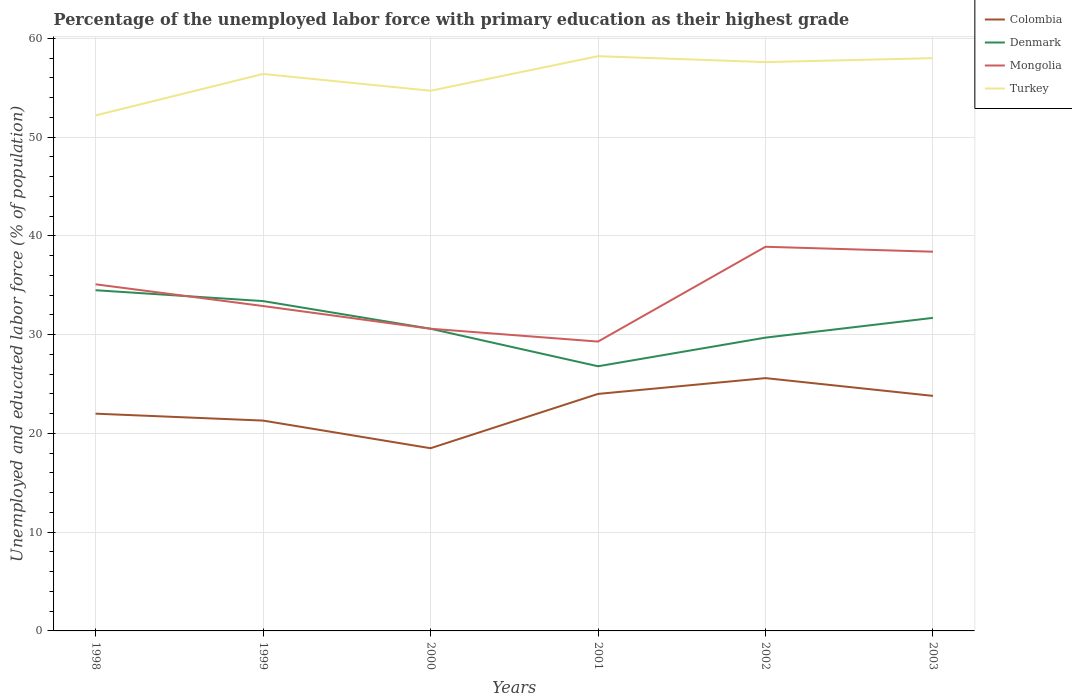Across all years, what is the maximum percentage of the unemployed labor force with primary education in Denmark?
Give a very brief answer. 26.8. What is the total percentage of the unemployed labor force with primary education in Mongolia in the graph?
Offer a terse response. -7.8. What is the difference between the highest and the second highest percentage of the unemployed labor force with primary education in Turkey?
Give a very brief answer. 6. How many lines are there?
Your answer should be very brief. 4. What is the difference between two consecutive major ticks on the Y-axis?
Your answer should be compact. 10. How are the legend labels stacked?
Ensure brevity in your answer.  Vertical. What is the title of the graph?
Provide a short and direct response. Percentage of the unemployed labor force with primary education as their highest grade. Does "Israel" appear as one of the legend labels in the graph?
Your answer should be very brief. No. What is the label or title of the X-axis?
Your response must be concise. Years. What is the label or title of the Y-axis?
Your answer should be very brief. Unemployed and educated labor force (% of population). What is the Unemployed and educated labor force (% of population) in Colombia in 1998?
Your answer should be compact. 22. What is the Unemployed and educated labor force (% of population) in Denmark in 1998?
Your response must be concise. 34.5. What is the Unemployed and educated labor force (% of population) in Mongolia in 1998?
Offer a very short reply. 35.1. What is the Unemployed and educated labor force (% of population) of Turkey in 1998?
Your answer should be very brief. 52.2. What is the Unemployed and educated labor force (% of population) of Colombia in 1999?
Make the answer very short. 21.3. What is the Unemployed and educated labor force (% of population) in Denmark in 1999?
Provide a succinct answer. 33.4. What is the Unemployed and educated labor force (% of population) of Mongolia in 1999?
Ensure brevity in your answer.  32.9. What is the Unemployed and educated labor force (% of population) in Turkey in 1999?
Keep it short and to the point. 56.4. What is the Unemployed and educated labor force (% of population) of Denmark in 2000?
Make the answer very short. 30.6. What is the Unemployed and educated labor force (% of population) in Mongolia in 2000?
Provide a succinct answer. 30.6. What is the Unemployed and educated labor force (% of population) of Turkey in 2000?
Offer a very short reply. 54.7. What is the Unemployed and educated labor force (% of population) in Denmark in 2001?
Give a very brief answer. 26.8. What is the Unemployed and educated labor force (% of population) of Mongolia in 2001?
Your response must be concise. 29.3. What is the Unemployed and educated labor force (% of population) of Turkey in 2001?
Your answer should be compact. 58.2. What is the Unemployed and educated labor force (% of population) in Colombia in 2002?
Give a very brief answer. 25.6. What is the Unemployed and educated labor force (% of population) in Denmark in 2002?
Your answer should be very brief. 29.7. What is the Unemployed and educated labor force (% of population) in Mongolia in 2002?
Ensure brevity in your answer.  38.9. What is the Unemployed and educated labor force (% of population) in Turkey in 2002?
Give a very brief answer. 57.6. What is the Unemployed and educated labor force (% of population) of Colombia in 2003?
Make the answer very short. 23.8. What is the Unemployed and educated labor force (% of population) in Denmark in 2003?
Offer a terse response. 31.7. What is the Unemployed and educated labor force (% of population) of Mongolia in 2003?
Give a very brief answer. 38.4. What is the Unemployed and educated labor force (% of population) of Turkey in 2003?
Provide a short and direct response. 58. Across all years, what is the maximum Unemployed and educated labor force (% of population) of Colombia?
Keep it short and to the point. 25.6. Across all years, what is the maximum Unemployed and educated labor force (% of population) of Denmark?
Offer a terse response. 34.5. Across all years, what is the maximum Unemployed and educated labor force (% of population) in Mongolia?
Offer a terse response. 38.9. Across all years, what is the maximum Unemployed and educated labor force (% of population) in Turkey?
Provide a succinct answer. 58.2. Across all years, what is the minimum Unemployed and educated labor force (% of population) in Colombia?
Offer a terse response. 18.5. Across all years, what is the minimum Unemployed and educated labor force (% of population) in Denmark?
Offer a very short reply. 26.8. Across all years, what is the minimum Unemployed and educated labor force (% of population) in Mongolia?
Offer a terse response. 29.3. Across all years, what is the minimum Unemployed and educated labor force (% of population) of Turkey?
Your response must be concise. 52.2. What is the total Unemployed and educated labor force (% of population) in Colombia in the graph?
Ensure brevity in your answer.  135.2. What is the total Unemployed and educated labor force (% of population) in Denmark in the graph?
Make the answer very short. 186.7. What is the total Unemployed and educated labor force (% of population) of Mongolia in the graph?
Offer a terse response. 205.2. What is the total Unemployed and educated labor force (% of population) in Turkey in the graph?
Give a very brief answer. 337.1. What is the difference between the Unemployed and educated labor force (% of population) of Colombia in 1998 and that in 1999?
Offer a very short reply. 0.7. What is the difference between the Unemployed and educated labor force (% of population) in Mongolia in 1998 and that in 1999?
Keep it short and to the point. 2.2. What is the difference between the Unemployed and educated labor force (% of population) of Colombia in 1998 and that in 2000?
Your answer should be very brief. 3.5. What is the difference between the Unemployed and educated labor force (% of population) of Denmark in 1998 and that in 2000?
Provide a succinct answer. 3.9. What is the difference between the Unemployed and educated labor force (% of population) of Mongolia in 1998 and that in 2000?
Your answer should be compact. 4.5. What is the difference between the Unemployed and educated labor force (% of population) in Turkey in 1998 and that in 2000?
Keep it short and to the point. -2.5. What is the difference between the Unemployed and educated labor force (% of population) of Colombia in 1998 and that in 2001?
Offer a very short reply. -2. What is the difference between the Unemployed and educated labor force (% of population) in Denmark in 1998 and that in 2001?
Your response must be concise. 7.7. What is the difference between the Unemployed and educated labor force (% of population) in Colombia in 1998 and that in 2002?
Give a very brief answer. -3.6. What is the difference between the Unemployed and educated labor force (% of population) of Turkey in 1998 and that in 2002?
Your answer should be very brief. -5.4. What is the difference between the Unemployed and educated labor force (% of population) of Colombia in 1998 and that in 2003?
Give a very brief answer. -1.8. What is the difference between the Unemployed and educated labor force (% of population) in Mongolia in 1998 and that in 2003?
Provide a succinct answer. -3.3. What is the difference between the Unemployed and educated labor force (% of population) of Colombia in 1999 and that in 2000?
Offer a very short reply. 2.8. What is the difference between the Unemployed and educated labor force (% of population) in Turkey in 1999 and that in 2000?
Provide a succinct answer. 1.7. What is the difference between the Unemployed and educated labor force (% of population) of Colombia in 1999 and that in 2001?
Ensure brevity in your answer.  -2.7. What is the difference between the Unemployed and educated labor force (% of population) of Mongolia in 1999 and that in 2001?
Your response must be concise. 3.6. What is the difference between the Unemployed and educated labor force (% of population) in Turkey in 1999 and that in 2001?
Offer a terse response. -1.8. What is the difference between the Unemployed and educated labor force (% of population) in Colombia in 1999 and that in 2002?
Give a very brief answer. -4.3. What is the difference between the Unemployed and educated labor force (% of population) in Turkey in 1999 and that in 2002?
Keep it short and to the point. -1.2. What is the difference between the Unemployed and educated labor force (% of population) in Colombia in 1999 and that in 2003?
Make the answer very short. -2.5. What is the difference between the Unemployed and educated labor force (% of population) of Mongolia in 1999 and that in 2003?
Your answer should be very brief. -5.5. What is the difference between the Unemployed and educated labor force (% of population) of Colombia in 2000 and that in 2002?
Keep it short and to the point. -7.1. What is the difference between the Unemployed and educated labor force (% of population) of Denmark in 2000 and that in 2002?
Your answer should be compact. 0.9. What is the difference between the Unemployed and educated labor force (% of population) in Mongolia in 2000 and that in 2003?
Ensure brevity in your answer.  -7.8. What is the difference between the Unemployed and educated labor force (% of population) in Turkey in 2000 and that in 2003?
Your answer should be very brief. -3.3. What is the difference between the Unemployed and educated labor force (% of population) of Colombia in 2001 and that in 2002?
Offer a terse response. -1.6. What is the difference between the Unemployed and educated labor force (% of population) in Mongolia in 2001 and that in 2002?
Make the answer very short. -9.6. What is the difference between the Unemployed and educated labor force (% of population) in Turkey in 2001 and that in 2002?
Ensure brevity in your answer.  0.6. What is the difference between the Unemployed and educated labor force (% of population) of Mongolia in 2001 and that in 2003?
Offer a very short reply. -9.1. What is the difference between the Unemployed and educated labor force (% of population) in Colombia in 2002 and that in 2003?
Give a very brief answer. 1.8. What is the difference between the Unemployed and educated labor force (% of population) of Denmark in 2002 and that in 2003?
Ensure brevity in your answer.  -2. What is the difference between the Unemployed and educated labor force (% of population) in Turkey in 2002 and that in 2003?
Make the answer very short. -0.4. What is the difference between the Unemployed and educated labor force (% of population) in Colombia in 1998 and the Unemployed and educated labor force (% of population) in Mongolia in 1999?
Offer a terse response. -10.9. What is the difference between the Unemployed and educated labor force (% of population) of Colombia in 1998 and the Unemployed and educated labor force (% of population) of Turkey in 1999?
Make the answer very short. -34.4. What is the difference between the Unemployed and educated labor force (% of population) of Denmark in 1998 and the Unemployed and educated labor force (% of population) of Turkey in 1999?
Ensure brevity in your answer.  -21.9. What is the difference between the Unemployed and educated labor force (% of population) of Mongolia in 1998 and the Unemployed and educated labor force (% of population) of Turkey in 1999?
Ensure brevity in your answer.  -21.3. What is the difference between the Unemployed and educated labor force (% of population) of Colombia in 1998 and the Unemployed and educated labor force (% of population) of Turkey in 2000?
Provide a succinct answer. -32.7. What is the difference between the Unemployed and educated labor force (% of population) of Denmark in 1998 and the Unemployed and educated labor force (% of population) of Mongolia in 2000?
Your response must be concise. 3.9. What is the difference between the Unemployed and educated labor force (% of population) of Denmark in 1998 and the Unemployed and educated labor force (% of population) of Turkey in 2000?
Provide a succinct answer. -20.2. What is the difference between the Unemployed and educated labor force (% of population) in Mongolia in 1998 and the Unemployed and educated labor force (% of population) in Turkey in 2000?
Ensure brevity in your answer.  -19.6. What is the difference between the Unemployed and educated labor force (% of population) of Colombia in 1998 and the Unemployed and educated labor force (% of population) of Denmark in 2001?
Ensure brevity in your answer.  -4.8. What is the difference between the Unemployed and educated labor force (% of population) in Colombia in 1998 and the Unemployed and educated labor force (% of population) in Mongolia in 2001?
Offer a terse response. -7.3. What is the difference between the Unemployed and educated labor force (% of population) of Colombia in 1998 and the Unemployed and educated labor force (% of population) of Turkey in 2001?
Your response must be concise. -36.2. What is the difference between the Unemployed and educated labor force (% of population) of Denmark in 1998 and the Unemployed and educated labor force (% of population) of Turkey in 2001?
Ensure brevity in your answer.  -23.7. What is the difference between the Unemployed and educated labor force (% of population) in Mongolia in 1998 and the Unemployed and educated labor force (% of population) in Turkey in 2001?
Keep it short and to the point. -23.1. What is the difference between the Unemployed and educated labor force (% of population) in Colombia in 1998 and the Unemployed and educated labor force (% of population) in Denmark in 2002?
Provide a succinct answer. -7.7. What is the difference between the Unemployed and educated labor force (% of population) in Colombia in 1998 and the Unemployed and educated labor force (% of population) in Mongolia in 2002?
Your answer should be very brief. -16.9. What is the difference between the Unemployed and educated labor force (% of population) in Colombia in 1998 and the Unemployed and educated labor force (% of population) in Turkey in 2002?
Ensure brevity in your answer.  -35.6. What is the difference between the Unemployed and educated labor force (% of population) in Denmark in 1998 and the Unemployed and educated labor force (% of population) in Mongolia in 2002?
Offer a terse response. -4.4. What is the difference between the Unemployed and educated labor force (% of population) in Denmark in 1998 and the Unemployed and educated labor force (% of population) in Turkey in 2002?
Give a very brief answer. -23.1. What is the difference between the Unemployed and educated labor force (% of population) in Mongolia in 1998 and the Unemployed and educated labor force (% of population) in Turkey in 2002?
Provide a short and direct response. -22.5. What is the difference between the Unemployed and educated labor force (% of population) in Colombia in 1998 and the Unemployed and educated labor force (% of population) in Denmark in 2003?
Provide a short and direct response. -9.7. What is the difference between the Unemployed and educated labor force (% of population) of Colombia in 1998 and the Unemployed and educated labor force (% of population) of Mongolia in 2003?
Keep it short and to the point. -16.4. What is the difference between the Unemployed and educated labor force (% of population) in Colombia in 1998 and the Unemployed and educated labor force (% of population) in Turkey in 2003?
Keep it short and to the point. -36. What is the difference between the Unemployed and educated labor force (% of population) of Denmark in 1998 and the Unemployed and educated labor force (% of population) of Turkey in 2003?
Keep it short and to the point. -23.5. What is the difference between the Unemployed and educated labor force (% of population) in Mongolia in 1998 and the Unemployed and educated labor force (% of population) in Turkey in 2003?
Your response must be concise. -22.9. What is the difference between the Unemployed and educated labor force (% of population) in Colombia in 1999 and the Unemployed and educated labor force (% of population) in Denmark in 2000?
Ensure brevity in your answer.  -9.3. What is the difference between the Unemployed and educated labor force (% of population) of Colombia in 1999 and the Unemployed and educated labor force (% of population) of Turkey in 2000?
Offer a very short reply. -33.4. What is the difference between the Unemployed and educated labor force (% of population) in Denmark in 1999 and the Unemployed and educated labor force (% of population) in Mongolia in 2000?
Provide a short and direct response. 2.8. What is the difference between the Unemployed and educated labor force (% of population) of Denmark in 1999 and the Unemployed and educated labor force (% of population) of Turkey in 2000?
Give a very brief answer. -21.3. What is the difference between the Unemployed and educated labor force (% of population) of Mongolia in 1999 and the Unemployed and educated labor force (% of population) of Turkey in 2000?
Make the answer very short. -21.8. What is the difference between the Unemployed and educated labor force (% of population) in Colombia in 1999 and the Unemployed and educated labor force (% of population) in Mongolia in 2001?
Offer a very short reply. -8. What is the difference between the Unemployed and educated labor force (% of population) of Colombia in 1999 and the Unemployed and educated labor force (% of population) of Turkey in 2001?
Your response must be concise. -36.9. What is the difference between the Unemployed and educated labor force (% of population) in Denmark in 1999 and the Unemployed and educated labor force (% of population) in Mongolia in 2001?
Your response must be concise. 4.1. What is the difference between the Unemployed and educated labor force (% of population) in Denmark in 1999 and the Unemployed and educated labor force (% of population) in Turkey in 2001?
Your response must be concise. -24.8. What is the difference between the Unemployed and educated labor force (% of population) of Mongolia in 1999 and the Unemployed and educated labor force (% of population) of Turkey in 2001?
Ensure brevity in your answer.  -25.3. What is the difference between the Unemployed and educated labor force (% of population) in Colombia in 1999 and the Unemployed and educated labor force (% of population) in Mongolia in 2002?
Provide a short and direct response. -17.6. What is the difference between the Unemployed and educated labor force (% of population) of Colombia in 1999 and the Unemployed and educated labor force (% of population) of Turkey in 2002?
Keep it short and to the point. -36.3. What is the difference between the Unemployed and educated labor force (% of population) of Denmark in 1999 and the Unemployed and educated labor force (% of population) of Turkey in 2002?
Provide a short and direct response. -24.2. What is the difference between the Unemployed and educated labor force (% of population) of Mongolia in 1999 and the Unemployed and educated labor force (% of population) of Turkey in 2002?
Offer a very short reply. -24.7. What is the difference between the Unemployed and educated labor force (% of population) of Colombia in 1999 and the Unemployed and educated labor force (% of population) of Denmark in 2003?
Your response must be concise. -10.4. What is the difference between the Unemployed and educated labor force (% of population) in Colombia in 1999 and the Unemployed and educated labor force (% of population) in Mongolia in 2003?
Keep it short and to the point. -17.1. What is the difference between the Unemployed and educated labor force (% of population) of Colombia in 1999 and the Unemployed and educated labor force (% of population) of Turkey in 2003?
Your answer should be compact. -36.7. What is the difference between the Unemployed and educated labor force (% of population) of Denmark in 1999 and the Unemployed and educated labor force (% of population) of Mongolia in 2003?
Keep it short and to the point. -5. What is the difference between the Unemployed and educated labor force (% of population) of Denmark in 1999 and the Unemployed and educated labor force (% of population) of Turkey in 2003?
Your answer should be very brief. -24.6. What is the difference between the Unemployed and educated labor force (% of population) of Mongolia in 1999 and the Unemployed and educated labor force (% of population) of Turkey in 2003?
Offer a terse response. -25.1. What is the difference between the Unemployed and educated labor force (% of population) of Colombia in 2000 and the Unemployed and educated labor force (% of population) of Mongolia in 2001?
Ensure brevity in your answer.  -10.8. What is the difference between the Unemployed and educated labor force (% of population) in Colombia in 2000 and the Unemployed and educated labor force (% of population) in Turkey in 2001?
Your response must be concise. -39.7. What is the difference between the Unemployed and educated labor force (% of population) in Denmark in 2000 and the Unemployed and educated labor force (% of population) in Turkey in 2001?
Provide a succinct answer. -27.6. What is the difference between the Unemployed and educated labor force (% of population) of Mongolia in 2000 and the Unemployed and educated labor force (% of population) of Turkey in 2001?
Provide a succinct answer. -27.6. What is the difference between the Unemployed and educated labor force (% of population) in Colombia in 2000 and the Unemployed and educated labor force (% of population) in Denmark in 2002?
Your answer should be compact. -11.2. What is the difference between the Unemployed and educated labor force (% of population) in Colombia in 2000 and the Unemployed and educated labor force (% of population) in Mongolia in 2002?
Your answer should be compact. -20.4. What is the difference between the Unemployed and educated labor force (% of population) of Colombia in 2000 and the Unemployed and educated labor force (% of population) of Turkey in 2002?
Provide a short and direct response. -39.1. What is the difference between the Unemployed and educated labor force (% of population) of Denmark in 2000 and the Unemployed and educated labor force (% of population) of Mongolia in 2002?
Provide a short and direct response. -8.3. What is the difference between the Unemployed and educated labor force (% of population) of Colombia in 2000 and the Unemployed and educated labor force (% of population) of Mongolia in 2003?
Your answer should be compact. -19.9. What is the difference between the Unemployed and educated labor force (% of population) of Colombia in 2000 and the Unemployed and educated labor force (% of population) of Turkey in 2003?
Provide a short and direct response. -39.5. What is the difference between the Unemployed and educated labor force (% of population) in Denmark in 2000 and the Unemployed and educated labor force (% of population) in Turkey in 2003?
Give a very brief answer. -27.4. What is the difference between the Unemployed and educated labor force (% of population) of Mongolia in 2000 and the Unemployed and educated labor force (% of population) of Turkey in 2003?
Give a very brief answer. -27.4. What is the difference between the Unemployed and educated labor force (% of population) in Colombia in 2001 and the Unemployed and educated labor force (% of population) in Denmark in 2002?
Ensure brevity in your answer.  -5.7. What is the difference between the Unemployed and educated labor force (% of population) in Colombia in 2001 and the Unemployed and educated labor force (% of population) in Mongolia in 2002?
Make the answer very short. -14.9. What is the difference between the Unemployed and educated labor force (% of population) in Colombia in 2001 and the Unemployed and educated labor force (% of population) in Turkey in 2002?
Give a very brief answer. -33.6. What is the difference between the Unemployed and educated labor force (% of population) in Denmark in 2001 and the Unemployed and educated labor force (% of population) in Turkey in 2002?
Your answer should be very brief. -30.8. What is the difference between the Unemployed and educated labor force (% of population) of Mongolia in 2001 and the Unemployed and educated labor force (% of population) of Turkey in 2002?
Provide a succinct answer. -28.3. What is the difference between the Unemployed and educated labor force (% of population) in Colombia in 2001 and the Unemployed and educated labor force (% of population) in Denmark in 2003?
Offer a very short reply. -7.7. What is the difference between the Unemployed and educated labor force (% of population) in Colombia in 2001 and the Unemployed and educated labor force (% of population) in Mongolia in 2003?
Provide a succinct answer. -14.4. What is the difference between the Unemployed and educated labor force (% of population) of Colombia in 2001 and the Unemployed and educated labor force (% of population) of Turkey in 2003?
Your response must be concise. -34. What is the difference between the Unemployed and educated labor force (% of population) of Denmark in 2001 and the Unemployed and educated labor force (% of population) of Turkey in 2003?
Your response must be concise. -31.2. What is the difference between the Unemployed and educated labor force (% of population) in Mongolia in 2001 and the Unemployed and educated labor force (% of population) in Turkey in 2003?
Your response must be concise. -28.7. What is the difference between the Unemployed and educated labor force (% of population) in Colombia in 2002 and the Unemployed and educated labor force (% of population) in Mongolia in 2003?
Provide a short and direct response. -12.8. What is the difference between the Unemployed and educated labor force (% of population) in Colombia in 2002 and the Unemployed and educated labor force (% of population) in Turkey in 2003?
Keep it short and to the point. -32.4. What is the difference between the Unemployed and educated labor force (% of population) in Denmark in 2002 and the Unemployed and educated labor force (% of population) in Turkey in 2003?
Keep it short and to the point. -28.3. What is the difference between the Unemployed and educated labor force (% of population) in Mongolia in 2002 and the Unemployed and educated labor force (% of population) in Turkey in 2003?
Ensure brevity in your answer.  -19.1. What is the average Unemployed and educated labor force (% of population) of Colombia per year?
Keep it short and to the point. 22.53. What is the average Unemployed and educated labor force (% of population) of Denmark per year?
Your answer should be compact. 31.12. What is the average Unemployed and educated labor force (% of population) of Mongolia per year?
Offer a terse response. 34.2. What is the average Unemployed and educated labor force (% of population) of Turkey per year?
Make the answer very short. 56.18. In the year 1998, what is the difference between the Unemployed and educated labor force (% of population) of Colombia and Unemployed and educated labor force (% of population) of Denmark?
Provide a short and direct response. -12.5. In the year 1998, what is the difference between the Unemployed and educated labor force (% of population) in Colombia and Unemployed and educated labor force (% of population) in Turkey?
Provide a succinct answer. -30.2. In the year 1998, what is the difference between the Unemployed and educated labor force (% of population) of Denmark and Unemployed and educated labor force (% of population) of Mongolia?
Make the answer very short. -0.6. In the year 1998, what is the difference between the Unemployed and educated labor force (% of population) of Denmark and Unemployed and educated labor force (% of population) of Turkey?
Your answer should be compact. -17.7. In the year 1998, what is the difference between the Unemployed and educated labor force (% of population) in Mongolia and Unemployed and educated labor force (% of population) in Turkey?
Keep it short and to the point. -17.1. In the year 1999, what is the difference between the Unemployed and educated labor force (% of population) of Colombia and Unemployed and educated labor force (% of population) of Denmark?
Offer a very short reply. -12.1. In the year 1999, what is the difference between the Unemployed and educated labor force (% of population) of Colombia and Unemployed and educated labor force (% of population) of Turkey?
Offer a terse response. -35.1. In the year 1999, what is the difference between the Unemployed and educated labor force (% of population) of Denmark and Unemployed and educated labor force (% of population) of Turkey?
Ensure brevity in your answer.  -23. In the year 1999, what is the difference between the Unemployed and educated labor force (% of population) in Mongolia and Unemployed and educated labor force (% of population) in Turkey?
Offer a very short reply. -23.5. In the year 2000, what is the difference between the Unemployed and educated labor force (% of population) of Colombia and Unemployed and educated labor force (% of population) of Denmark?
Make the answer very short. -12.1. In the year 2000, what is the difference between the Unemployed and educated labor force (% of population) of Colombia and Unemployed and educated labor force (% of population) of Mongolia?
Your answer should be very brief. -12.1. In the year 2000, what is the difference between the Unemployed and educated labor force (% of population) in Colombia and Unemployed and educated labor force (% of population) in Turkey?
Your answer should be very brief. -36.2. In the year 2000, what is the difference between the Unemployed and educated labor force (% of population) of Denmark and Unemployed and educated labor force (% of population) of Turkey?
Make the answer very short. -24.1. In the year 2000, what is the difference between the Unemployed and educated labor force (% of population) in Mongolia and Unemployed and educated labor force (% of population) in Turkey?
Offer a terse response. -24.1. In the year 2001, what is the difference between the Unemployed and educated labor force (% of population) in Colombia and Unemployed and educated labor force (% of population) in Denmark?
Make the answer very short. -2.8. In the year 2001, what is the difference between the Unemployed and educated labor force (% of population) in Colombia and Unemployed and educated labor force (% of population) in Mongolia?
Your response must be concise. -5.3. In the year 2001, what is the difference between the Unemployed and educated labor force (% of population) of Colombia and Unemployed and educated labor force (% of population) of Turkey?
Provide a succinct answer. -34.2. In the year 2001, what is the difference between the Unemployed and educated labor force (% of population) in Denmark and Unemployed and educated labor force (% of population) in Turkey?
Offer a terse response. -31.4. In the year 2001, what is the difference between the Unemployed and educated labor force (% of population) in Mongolia and Unemployed and educated labor force (% of population) in Turkey?
Ensure brevity in your answer.  -28.9. In the year 2002, what is the difference between the Unemployed and educated labor force (% of population) of Colombia and Unemployed and educated labor force (% of population) of Turkey?
Offer a terse response. -32. In the year 2002, what is the difference between the Unemployed and educated labor force (% of population) in Denmark and Unemployed and educated labor force (% of population) in Mongolia?
Provide a succinct answer. -9.2. In the year 2002, what is the difference between the Unemployed and educated labor force (% of population) in Denmark and Unemployed and educated labor force (% of population) in Turkey?
Your response must be concise. -27.9. In the year 2002, what is the difference between the Unemployed and educated labor force (% of population) of Mongolia and Unemployed and educated labor force (% of population) of Turkey?
Your response must be concise. -18.7. In the year 2003, what is the difference between the Unemployed and educated labor force (% of population) in Colombia and Unemployed and educated labor force (% of population) in Mongolia?
Keep it short and to the point. -14.6. In the year 2003, what is the difference between the Unemployed and educated labor force (% of population) of Colombia and Unemployed and educated labor force (% of population) of Turkey?
Your response must be concise. -34.2. In the year 2003, what is the difference between the Unemployed and educated labor force (% of population) of Denmark and Unemployed and educated labor force (% of population) of Turkey?
Keep it short and to the point. -26.3. In the year 2003, what is the difference between the Unemployed and educated labor force (% of population) of Mongolia and Unemployed and educated labor force (% of population) of Turkey?
Make the answer very short. -19.6. What is the ratio of the Unemployed and educated labor force (% of population) in Colombia in 1998 to that in 1999?
Your answer should be compact. 1.03. What is the ratio of the Unemployed and educated labor force (% of population) of Denmark in 1998 to that in 1999?
Provide a short and direct response. 1.03. What is the ratio of the Unemployed and educated labor force (% of population) in Mongolia in 1998 to that in 1999?
Offer a very short reply. 1.07. What is the ratio of the Unemployed and educated labor force (% of population) of Turkey in 1998 to that in 1999?
Give a very brief answer. 0.93. What is the ratio of the Unemployed and educated labor force (% of population) of Colombia in 1998 to that in 2000?
Your answer should be very brief. 1.19. What is the ratio of the Unemployed and educated labor force (% of population) of Denmark in 1998 to that in 2000?
Keep it short and to the point. 1.13. What is the ratio of the Unemployed and educated labor force (% of population) in Mongolia in 1998 to that in 2000?
Give a very brief answer. 1.15. What is the ratio of the Unemployed and educated labor force (% of population) in Turkey in 1998 to that in 2000?
Your response must be concise. 0.95. What is the ratio of the Unemployed and educated labor force (% of population) in Colombia in 1998 to that in 2001?
Your response must be concise. 0.92. What is the ratio of the Unemployed and educated labor force (% of population) of Denmark in 1998 to that in 2001?
Make the answer very short. 1.29. What is the ratio of the Unemployed and educated labor force (% of population) in Mongolia in 1998 to that in 2001?
Your response must be concise. 1.2. What is the ratio of the Unemployed and educated labor force (% of population) in Turkey in 1998 to that in 2001?
Make the answer very short. 0.9. What is the ratio of the Unemployed and educated labor force (% of population) of Colombia in 1998 to that in 2002?
Your answer should be very brief. 0.86. What is the ratio of the Unemployed and educated labor force (% of population) of Denmark in 1998 to that in 2002?
Ensure brevity in your answer.  1.16. What is the ratio of the Unemployed and educated labor force (% of population) of Mongolia in 1998 to that in 2002?
Keep it short and to the point. 0.9. What is the ratio of the Unemployed and educated labor force (% of population) in Turkey in 1998 to that in 2002?
Keep it short and to the point. 0.91. What is the ratio of the Unemployed and educated labor force (% of population) of Colombia in 1998 to that in 2003?
Give a very brief answer. 0.92. What is the ratio of the Unemployed and educated labor force (% of population) in Denmark in 1998 to that in 2003?
Provide a succinct answer. 1.09. What is the ratio of the Unemployed and educated labor force (% of population) in Mongolia in 1998 to that in 2003?
Ensure brevity in your answer.  0.91. What is the ratio of the Unemployed and educated labor force (% of population) of Turkey in 1998 to that in 2003?
Offer a terse response. 0.9. What is the ratio of the Unemployed and educated labor force (% of population) of Colombia in 1999 to that in 2000?
Make the answer very short. 1.15. What is the ratio of the Unemployed and educated labor force (% of population) of Denmark in 1999 to that in 2000?
Your answer should be very brief. 1.09. What is the ratio of the Unemployed and educated labor force (% of population) of Mongolia in 1999 to that in 2000?
Keep it short and to the point. 1.08. What is the ratio of the Unemployed and educated labor force (% of population) in Turkey in 1999 to that in 2000?
Offer a terse response. 1.03. What is the ratio of the Unemployed and educated labor force (% of population) in Colombia in 1999 to that in 2001?
Make the answer very short. 0.89. What is the ratio of the Unemployed and educated labor force (% of population) of Denmark in 1999 to that in 2001?
Make the answer very short. 1.25. What is the ratio of the Unemployed and educated labor force (% of population) of Mongolia in 1999 to that in 2001?
Your answer should be very brief. 1.12. What is the ratio of the Unemployed and educated labor force (% of population) in Turkey in 1999 to that in 2001?
Offer a terse response. 0.97. What is the ratio of the Unemployed and educated labor force (% of population) in Colombia in 1999 to that in 2002?
Your response must be concise. 0.83. What is the ratio of the Unemployed and educated labor force (% of population) of Denmark in 1999 to that in 2002?
Your answer should be compact. 1.12. What is the ratio of the Unemployed and educated labor force (% of population) in Mongolia in 1999 to that in 2002?
Make the answer very short. 0.85. What is the ratio of the Unemployed and educated labor force (% of population) in Turkey in 1999 to that in 2002?
Your answer should be compact. 0.98. What is the ratio of the Unemployed and educated labor force (% of population) in Colombia in 1999 to that in 2003?
Keep it short and to the point. 0.9. What is the ratio of the Unemployed and educated labor force (% of population) of Denmark in 1999 to that in 2003?
Ensure brevity in your answer.  1.05. What is the ratio of the Unemployed and educated labor force (% of population) of Mongolia in 1999 to that in 2003?
Your answer should be very brief. 0.86. What is the ratio of the Unemployed and educated labor force (% of population) of Turkey in 1999 to that in 2003?
Provide a succinct answer. 0.97. What is the ratio of the Unemployed and educated labor force (% of population) in Colombia in 2000 to that in 2001?
Give a very brief answer. 0.77. What is the ratio of the Unemployed and educated labor force (% of population) in Denmark in 2000 to that in 2001?
Your answer should be very brief. 1.14. What is the ratio of the Unemployed and educated labor force (% of population) in Mongolia in 2000 to that in 2001?
Ensure brevity in your answer.  1.04. What is the ratio of the Unemployed and educated labor force (% of population) of Turkey in 2000 to that in 2001?
Give a very brief answer. 0.94. What is the ratio of the Unemployed and educated labor force (% of population) in Colombia in 2000 to that in 2002?
Make the answer very short. 0.72. What is the ratio of the Unemployed and educated labor force (% of population) of Denmark in 2000 to that in 2002?
Ensure brevity in your answer.  1.03. What is the ratio of the Unemployed and educated labor force (% of population) in Mongolia in 2000 to that in 2002?
Keep it short and to the point. 0.79. What is the ratio of the Unemployed and educated labor force (% of population) in Turkey in 2000 to that in 2002?
Offer a very short reply. 0.95. What is the ratio of the Unemployed and educated labor force (% of population) of Colombia in 2000 to that in 2003?
Make the answer very short. 0.78. What is the ratio of the Unemployed and educated labor force (% of population) in Denmark in 2000 to that in 2003?
Your answer should be compact. 0.97. What is the ratio of the Unemployed and educated labor force (% of population) of Mongolia in 2000 to that in 2003?
Offer a terse response. 0.8. What is the ratio of the Unemployed and educated labor force (% of population) in Turkey in 2000 to that in 2003?
Your answer should be compact. 0.94. What is the ratio of the Unemployed and educated labor force (% of population) in Denmark in 2001 to that in 2002?
Your answer should be very brief. 0.9. What is the ratio of the Unemployed and educated labor force (% of population) in Mongolia in 2001 to that in 2002?
Provide a succinct answer. 0.75. What is the ratio of the Unemployed and educated labor force (% of population) of Turkey in 2001 to that in 2002?
Provide a short and direct response. 1.01. What is the ratio of the Unemployed and educated labor force (% of population) in Colombia in 2001 to that in 2003?
Give a very brief answer. 1.01. What is the ratio of the Unemployed and educated labor force (% of population) in Denmark in 2001 to that in 2003?
Keep it short and to the point. 0.85. What is the ratio of the Unemployed and educated labor force (% of population) in Mongolia in 2001 to that in 2003?
Your answer should be compact. 0.76. What is the ratio of the Unemployed and educated labor force (% of population) in Turkey in 2001 to that in 2003?
Provide a succinct answer. 1. What is the ratio of the Unemployed and educated labor force (% of population) in Colombia in 2002 to that in 2003?
Your response must be concise. 1.08. What is the ratio of the Unemployed and educated labor force (% of population) in Denmark in 2002 to that in 2003?
Give a very brief answer. 0.94. What is the ratio of the Unemployed and educated labor force (% of population) in Mongolia in 2002 to that in 2003?
Offer a very short reply. 1.01. What is the difference between the highest and the second highest Unemployed and educated labor force (% of population) in Colombia?
Keep it short and to the point. 1.6. What is the difference between the highest and the second highest Unemployed and educated labor force (% of population) of Denmark?
Your answer should be very brief. 1.1. What is the difference between the highest and the second highest Unemployed and educated labor force (% of population) in Turkey?
Give a very brief answer. 0.2. What is the difference between the highest and the lowest Unemployed and educated labor force (% of population) in Denmark?
Offer a terse response. 7.7. What is the difference between the highest and the lowest Unemployed and educated labor force (% of population) of Turkey?
Your answer should be very brief. 6. 